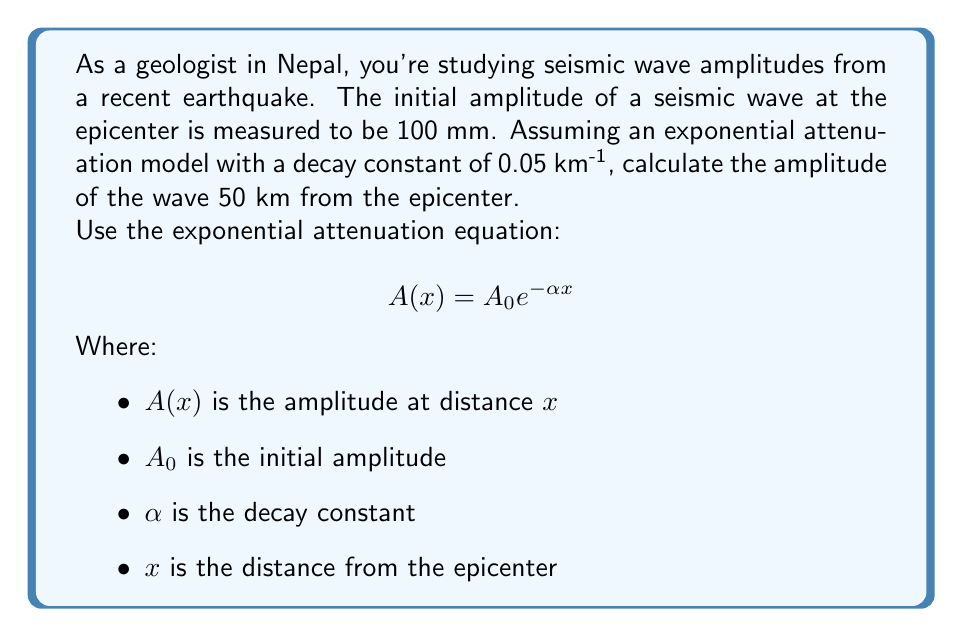Could you help me with this problem? To solve this problem, we'll use the exponential attenuation equation and plug in the given values:

$$ A(x) = A_0 e^{-\alpha x} $$

Given:
- Initial amplitude, $A_0 = 100$ mm
- Decay constant, $\alpha = 0.05$ km^(-1)
- Distance, $x = 50$ km

Step 1: Substitute the values into the equation:

$$ A(50) = 100 \cdot e^{-0.05 \cdot 50} $$

Step 2: Simplify the exponent:

$$ A(50) = 100 \cdot e^{-2.5} $$

Step 3: Calculate the value of $e^{-2.5}$ using a calculator:

$$ e^{-2.5} \approx 0.0821 $$

Step 4: Multiply by the initial amplitude:

$$ A(50) = 100 \cdot 0.0821 \approx 8.21 $$

Therefore, the amplitude of the seismic wave 50 km from the epicenter is approximately 8.21 mm.
Answer: $8.21$ mm 